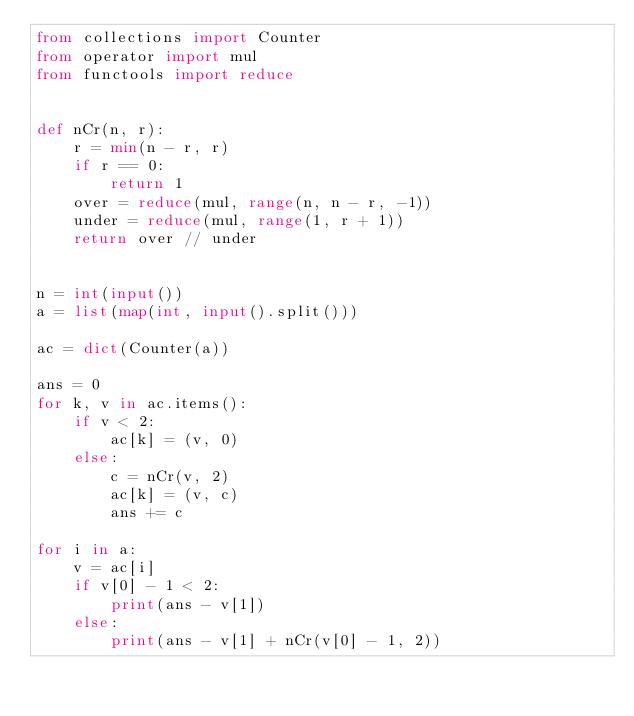<code> <loc_0><loc_0><loc_500><loc_500><_Python_>from collections import Counter
from operator import mul
from functools import reduce


def nCr(n, r):
    r = min(n - r, r)
    if r == 0:
        return 1
    over = reduce(mul, range(n, n - r, -1))
    under = reduce(mul, range(1, r + 1))
    return over // under


n = int(input())
a = list(map(int, input().split()))

ac = dict(Counter(a))

ans = 0
for k, v in ac.items():
    if v < 2:
        ac[k] = (v, 0)
    else:
        c = nCr(v, 2)
        ac[k] = (v, c)
        ans += c

for i in a:
    v = ac[i]
    if v[0] - 1 < 2:
        print(ans - v[1])
    else:
        print(ans - v[1] + nCr(v[0] - 1, 2))
</code> 